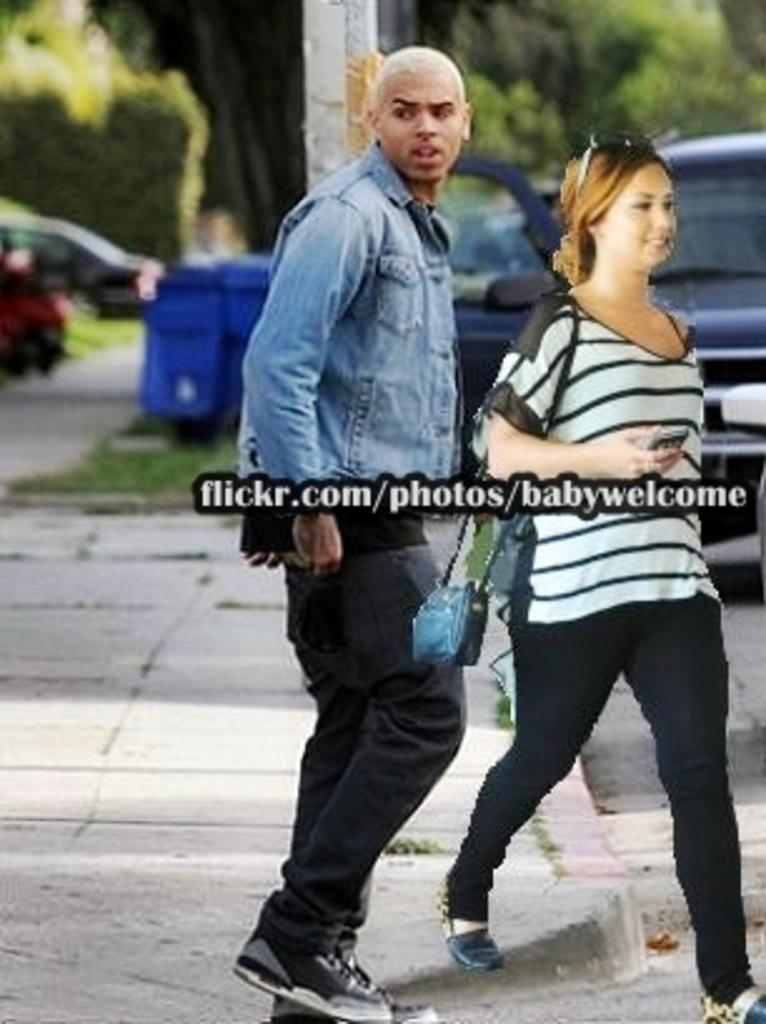What are the people in the image doing? The people in the image are walking. Where are the people located in the image? The people are in the middle of the image. What can be seen behind the people? There are vehicles and trees behind the people. What else is visible in the background of the image? There are poles in the background of the image. Reasoning: Let'ing: Let's think step by step in order to produce the conversation. We start by identifying the main action in the image, which is the people walking. Then, we describe the location of the people within the image. Next, we expand the conversation to include other objects and elements visible in the image, such as vehicles, trees, and poles. Each question is designed to elicit a specific detail about the image that is known from the provided facts. Absurd Question/Answer: What type of blade is being used to cut the cabbage in the image? There is no blade or cabbage present in the image; it features people walking with vehicles and trees in the background. 